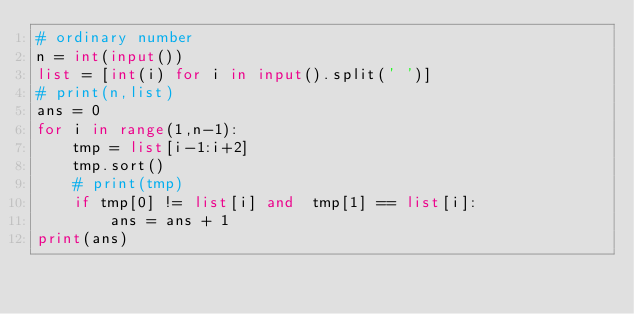<code> <loc_0><loc_0><loc_500><loc_500><_Python_># ordinary number
n = int(input())
list = [int(i) for i in input().split(' ')]
# print(n,list)
ans = 0
for i in range(1,n-1):
	tmp = list[i-1:i+2]
	tmp.sort()
	# print(tmp)
	if tmp[0] != list[i] and  tmp[1] == list[i]:
		ans = ans + 1
print(ans)
</code> 